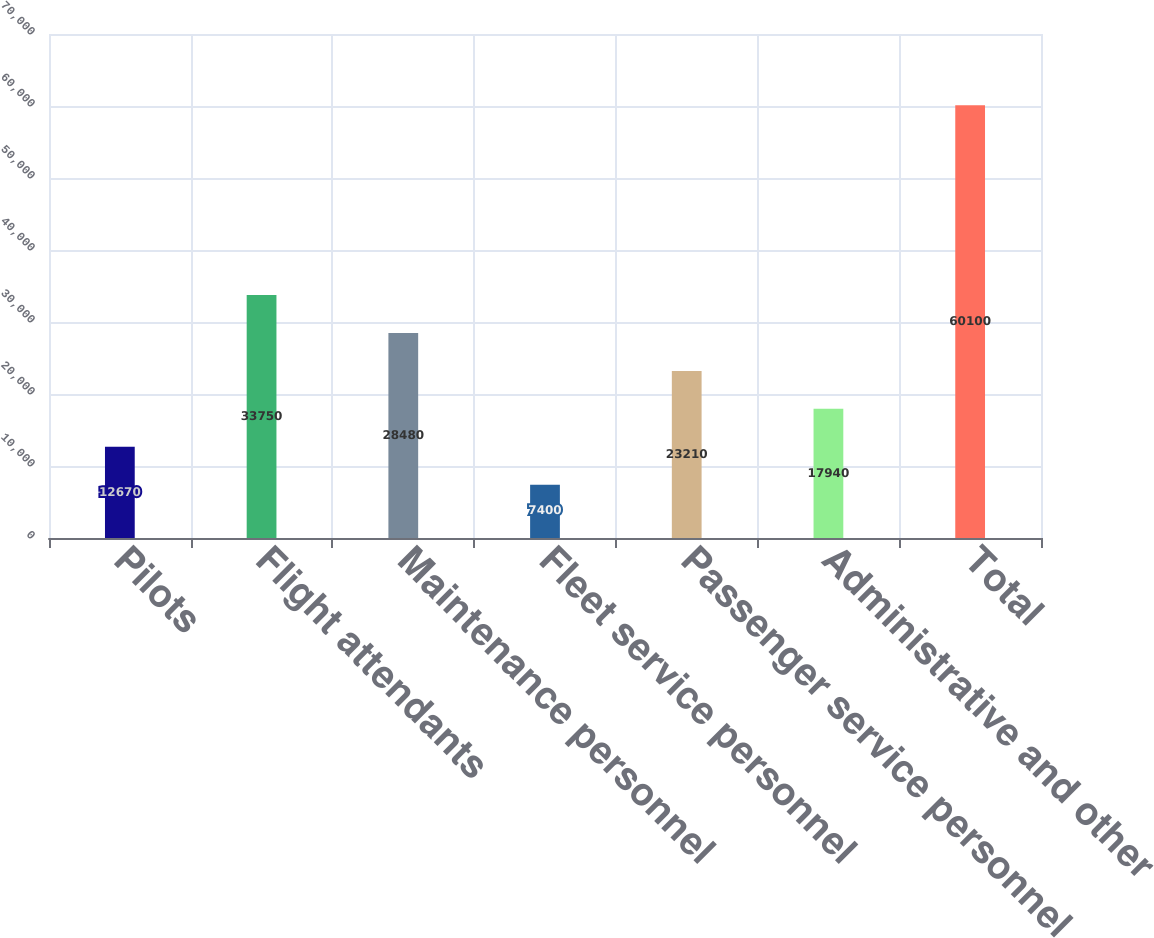<chart> <loc_0><loc_0><loc_500><loc_500><bar_chart><fcel>Pilots<fcel>Flight attendants<fcel>Maintenance personnel<fcel>Fleet service personnel<fcel>Passenger service personnel<fcel>Administrative and other<fcel>Total<nl><fcel>12670<fcel>33750<fcel>28480<fcel>7400<fcel>23210<fcel>17940<fcel>60100<nl></chart> 